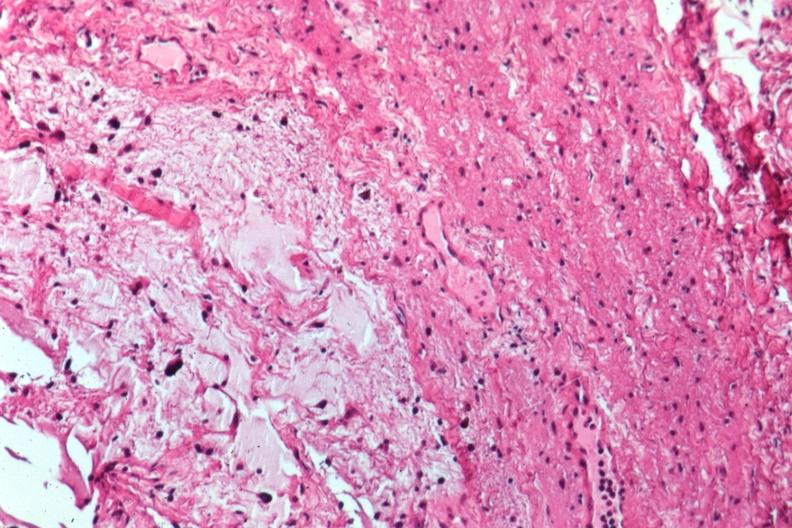what is present?
Answer the question using a single word or phrase. Eye 